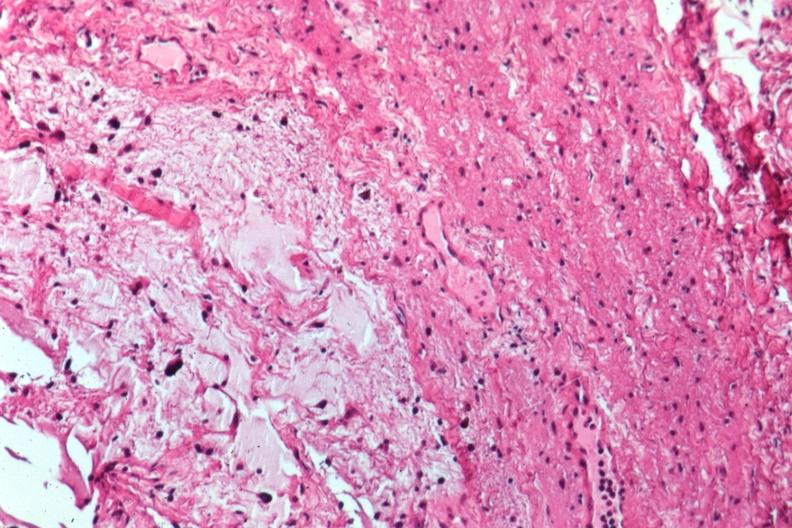what is present?
Answer the question using a single word or phrase. Eye 